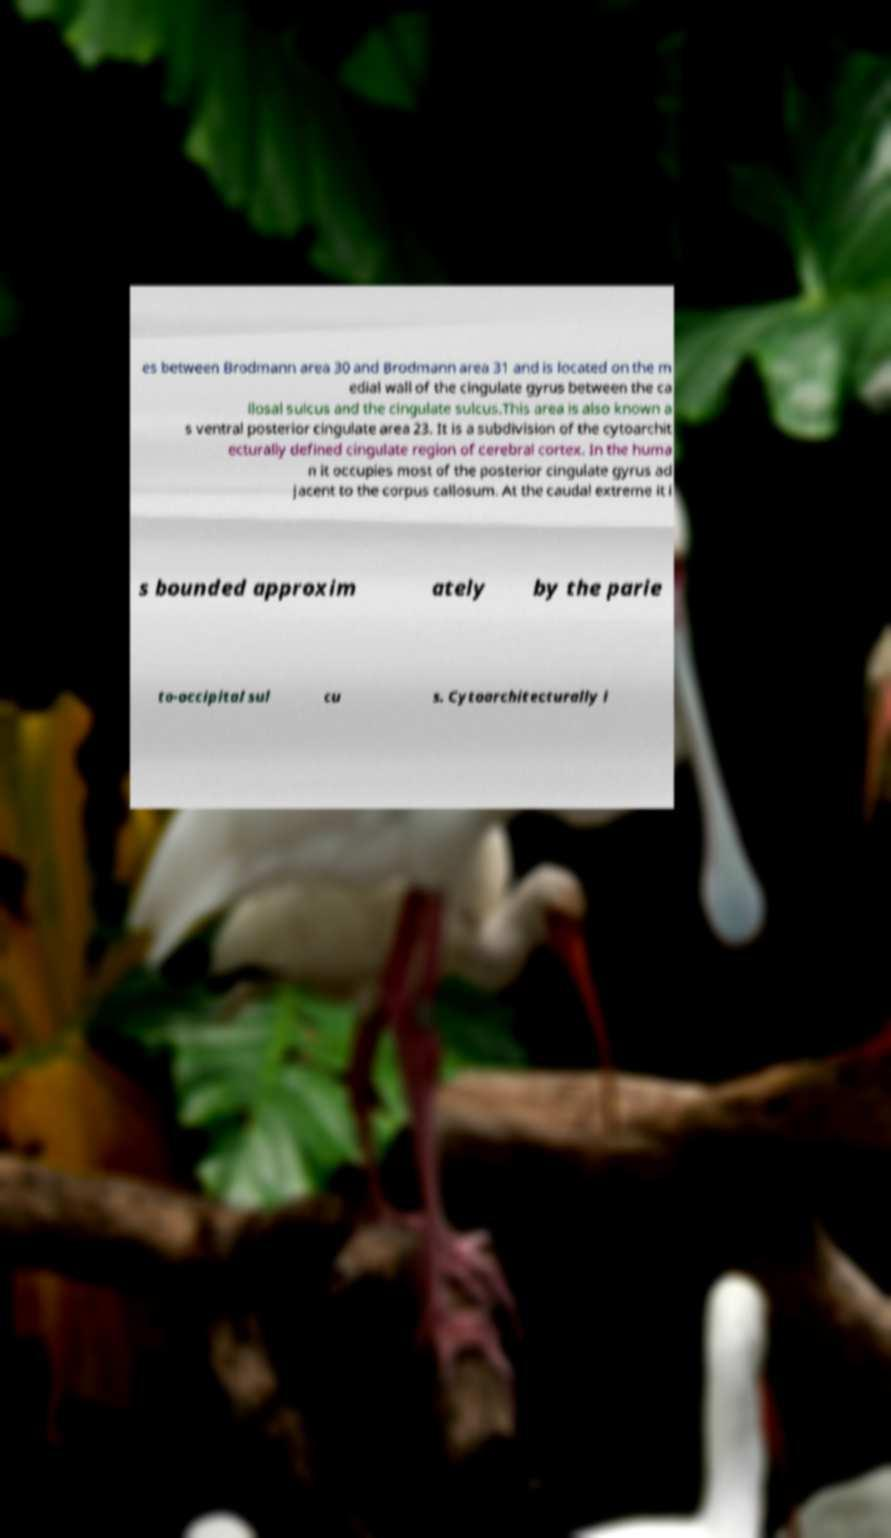Could you assist in decoding the text presented in this image and type it out clearly? es between Brodmann area 30 and Brodmann area 31 and is located on the m edial wall of the cingulate gyrus between the ca llosal sulcus and the cingulate sulcus.This area is also known a s ventral posterior cingulate area 23. It is a subdivision of the cytoarchit ecturally defined cingulate region of cerebral cortex. In the huma n it occupies most of the posterior cingulate gyrus ad jacent to the corpus callosum. At the caudal extreme it i s bounded approxim ately by the parie to-occipital sul cu s. Cytoarchitecturally i 